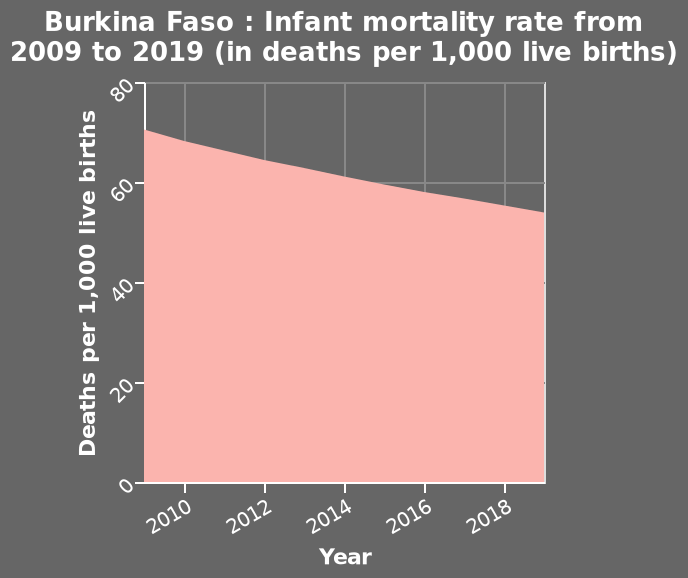<image>
In which country does the area graph represent the infant mortality rate? The area graph represents the infant mortality rate in Burkina Faso. In which year did the infant mortality rate reach 70? The infant mortality rate reached 70 in the year 2009. What does the y-axis of the area graph plot? The y-axis of the area graph plots Deaths per 1,000 live births. 